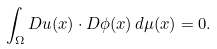Convert formula to latex. <formula><loc_0><loc_0><loc_500><loc_500>\int _ { \Omega } D u ( x ) \cdot D \phi ( x ) \, d \mu ( x ) = 0 .</formula> 